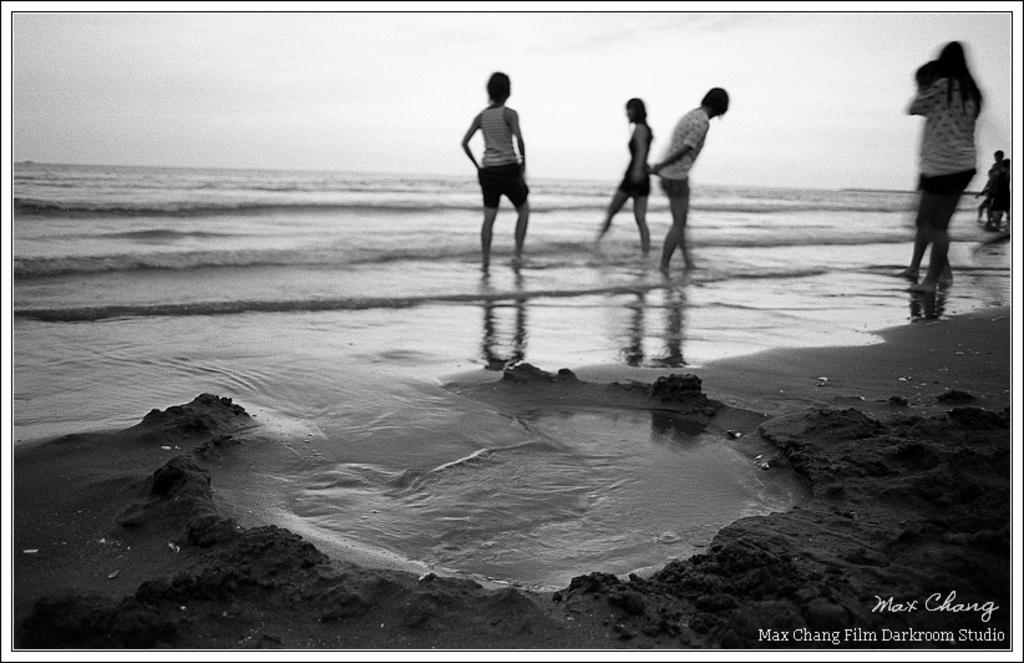Describe this image in one or two sentences. In the image we can see black and white picture of people standing and some of them are walking, they are wearing clothes. Here we can see the sand, the sea and the sky. On the bottom right we can see the watermark.  